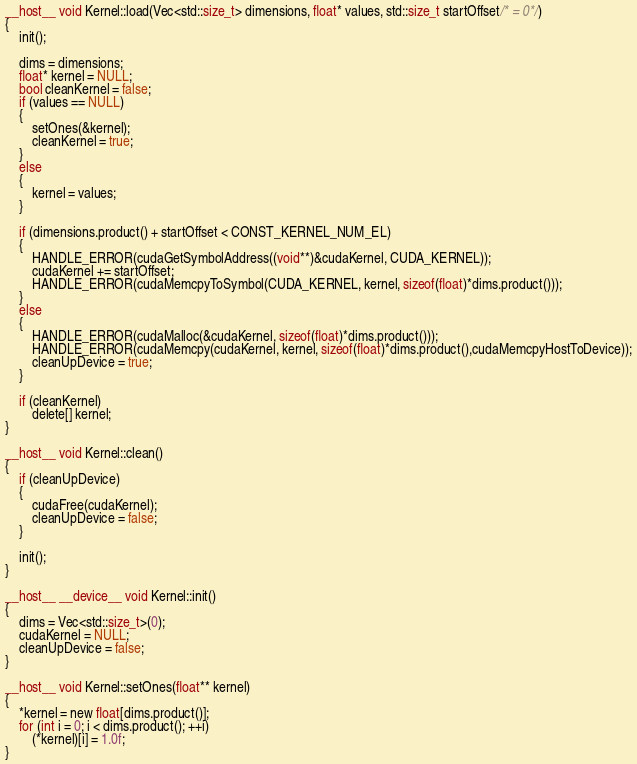<code> <loc_0><loc_0><loc_500><loc_500><_Cuda_>__host__ void Kernel::load(Vec<std::size_t> dimensions, float* values, std::size_t startOffset/* = 0*/)
{
	init();

	dims = dimensions;
	float* kernel = NULL;
	bool cleanKernel = false;
	if (values == NULL)
	{
		setOnes(&kernel);
		cleanKernel = true;
	}
	else
	{
		kernel = values;
	}

	if (dimensions.product() + startOffset < CONST_KERNEL_NUM_EL)
	{
		HANDLE_ERROR(cudaGetSymbolAddress((void**)&cudaKernel, CUDA_KERNEL));
		cudaKernel += startOffset;
		HANDLE_ERROR(cudaMemcpyToSymbol(CUDA_KERNEL, kernel, sizeof(float)*dims.product()));
	}
	else
	{
		HANDLE_ERROR(cudaMalloc(&cudaKernel, sizeof(float)*dims.product()));
		HANDLE_ERROR(cudaMemcpy(cudaKernel, kernel, sizeof(float)*dims.product(),cudaMemcpyHostToDevice));
		cleanUpDevice = true;
	}

	if (cleanKernel)
		delete[] kernel;
}

__host__ void Kernel::clean()
{
	if (cleanUpDevice)
	{
		cudaFree(cudaKernel);
		cleanUpDevice = false;
	}

	init();
}

__host__ __device__ void Kernel::init()
{
	dims = Vec<std::size_t>(0);
	cudaKernel = NULL;
	cleanUpDevice = false;
}

__host__ void Kernel::setOnes(float** kernel)
{
	*kernel = new float[dims.product()];
	for (int i = 0; i < dims.product(); ++i)
		(*kernel)[i] = 1.0f;
}
</code> 